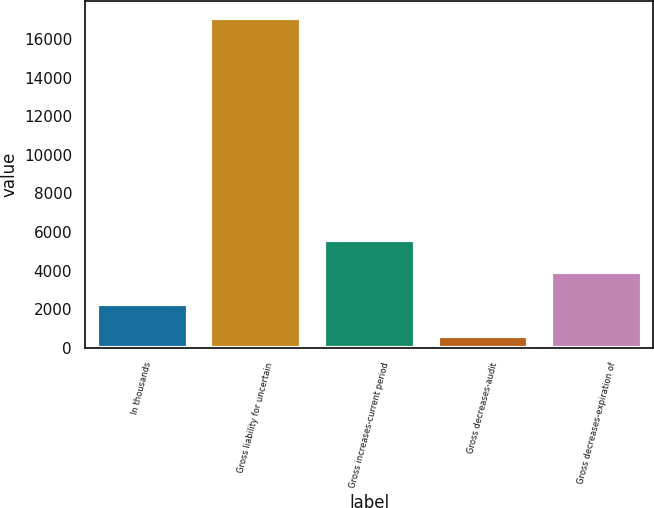Convert chart. <chart><loc_0><loc_0><loc_500><loc_500><bar_chart><fcel>In thousands<fcel>Gross liability for uncertain<fcel>Gross increases-current period<fcel>Gross decreases-audit<fcel>Gross decreases-expiration of<nl><fcel>2257.6<fcel>17102<fcel>5578.8<fcel>597<fcel>3918.2<nl></chart> 